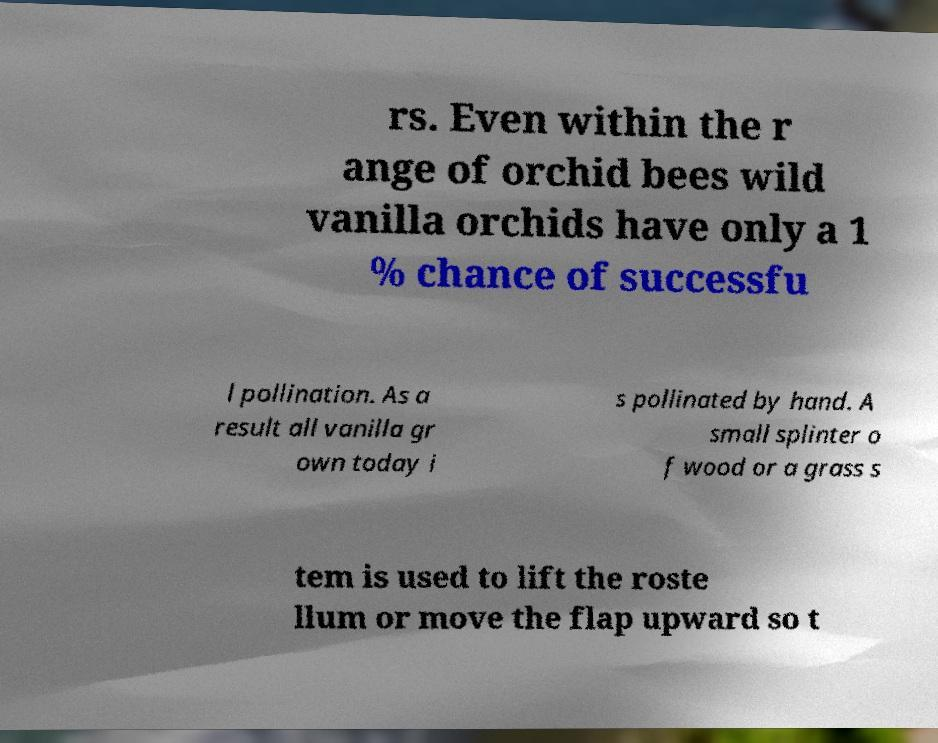Can you accurately transcribe the text from the provided image for me? rs. Even within the r ange of orchid bees wild vanilla orchids have only a 1 % chance of successfu l pollination. As a result all vanilla gr own today i s pollinated by hand. A small splinter o f wood or a grass s tem is used to lift the roste llum or move the flap upward so t 